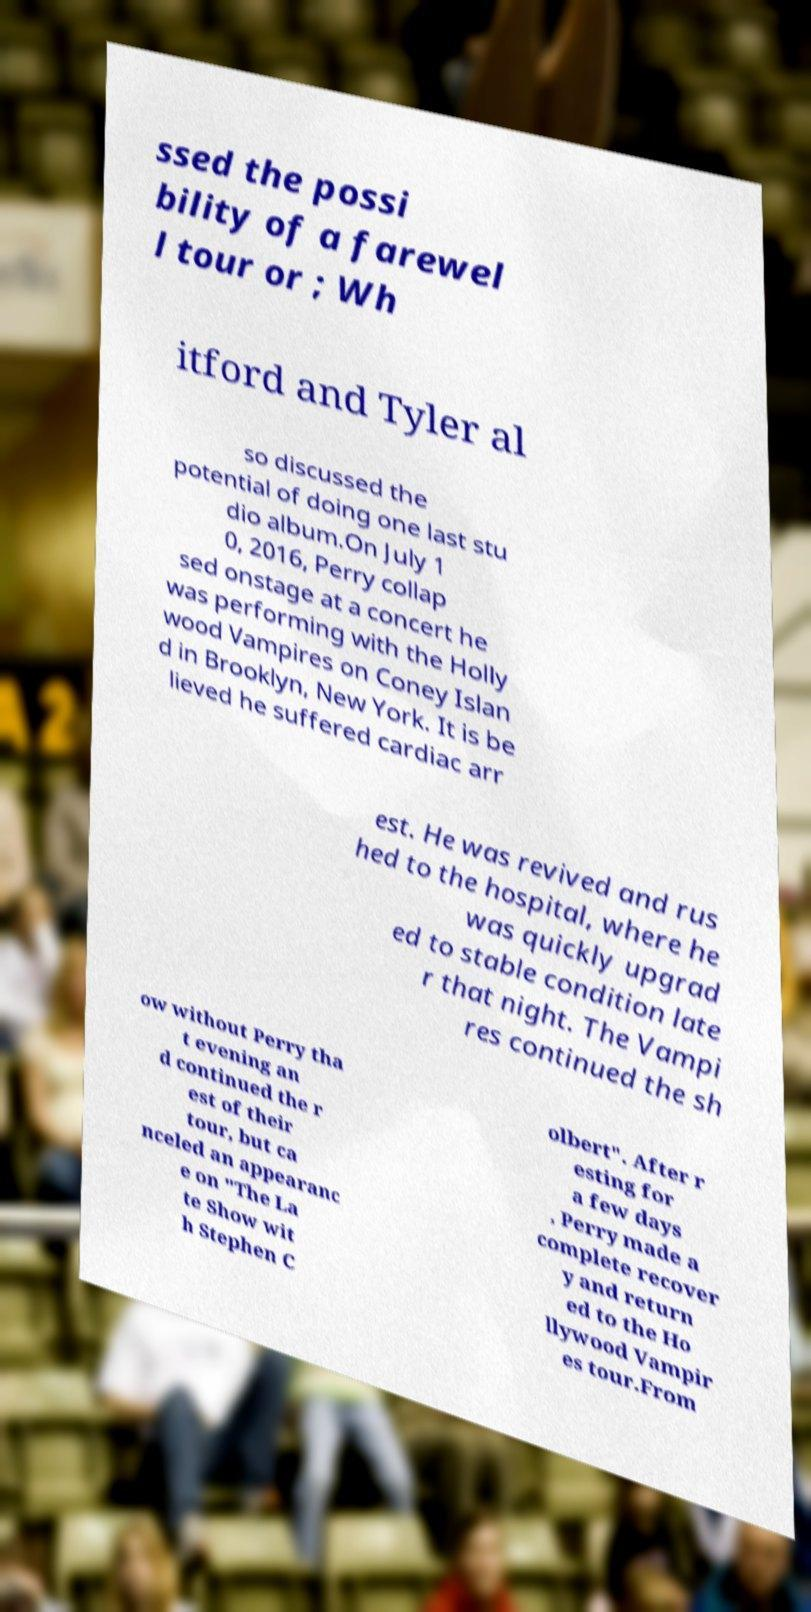There's text embedded in this image that I need extracted. Can you transcribe it verbatim? ssed the possi bility of a farewel l tour or ; Wh itford and Tyler al so discussed the potential of doing one last stu dio album.On July 1 0, 2016, Perry collap sed onstage at a concert he was performing with the Holly wood Vampires on Coney Islan d in Brooklyn, New York. It is be lieved he suffered cardiac arr est. He was revived and rus hed to the hospital, where he was quickly upgrad ed to stable condition late r that night. The Vampi res continued the sh ow without Perry tha t evening an d continued the r est of their tour, but ca nceled an appearanc e on "The La te Show wit h Stephen C olbert". After r esting for a few days , Perry made a complete recover y and return ed to the Ho llywood Vampir es tour.From 